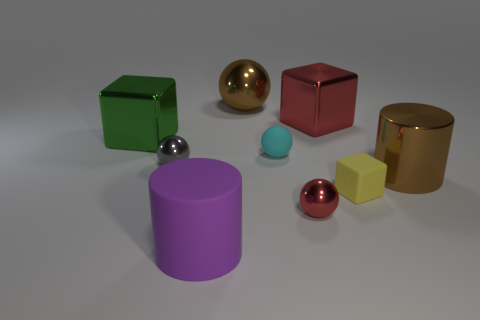Subtract all metallic blocks. How many blocks are left? 1 Subtract all red blocks. How many blocks are left? 2 Subtract 1 blocks. How many blocks are left? 2 Subtract all blocks. How many objects are left? 6 Add 6 green shiny cylinders. How many green shiny cylinders exist? 6 Subtract 0 purple spheres. How many objects are left? 9 Subtract all yellow cylinders. Subtract all brown cubes. How many cylinders are left? 2 Subtract all purple matte blocks. Subtract all cyan balls. How many objects are left? 8 Add 5 cyan matte balls. How many cyan matte balls are left? 6 